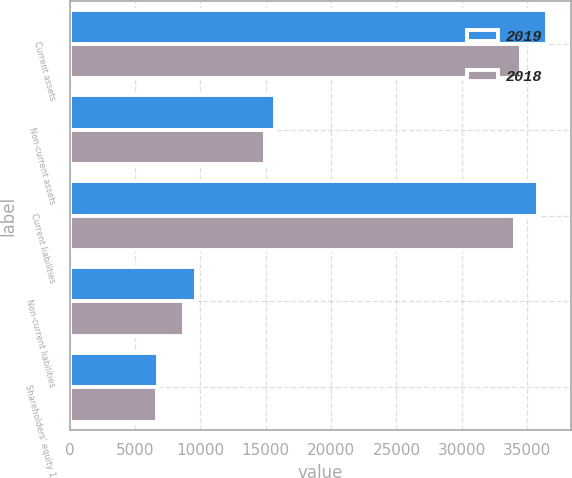<chart> <loc_0><loc_0><loc_500><loc_500><stacked_bar_chart><ecel><fcel>Current assets<fcel>Non-current assets<fcel>Current liabilities<fcel>Non-current liabilities<fcel>Shareholders' equity 1<nl><fcel>2019<fcel>36523<fcel>15710<fcel>35857<fcel>9633<fcel>6743<nl><fcel>2018<fcel>34493<fcel>14971<fcel>34055<fcel>8759<fcel>6650<nl></chart> 